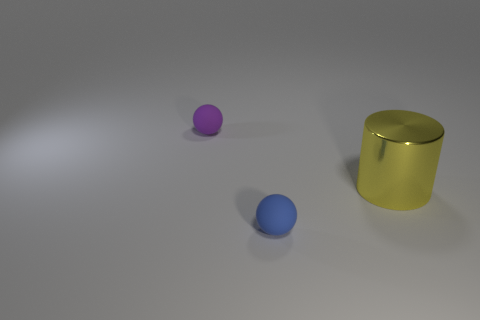Add 2 tiny red shiny balls. How many objects exist? 5 Subtract 1 balls. How many balls are left? 1 Subtract all red spheres. Subtract all green cylinders. How many spheres are left? 2 Subtract all purple cylinders. How many brown spheres are left? 0 Subtract all small blue rubber objects. Subtract all yellow metallic things. How many objects are left? 1 Add 2 yellow shiny things. How many yellow shiny things are left? 3 Add 2 red objects. How many red objects exist? 2 Subtract 0 yellow balls. How many objects are left? 3 Subtract all cylinders. How many objects are left? 2 